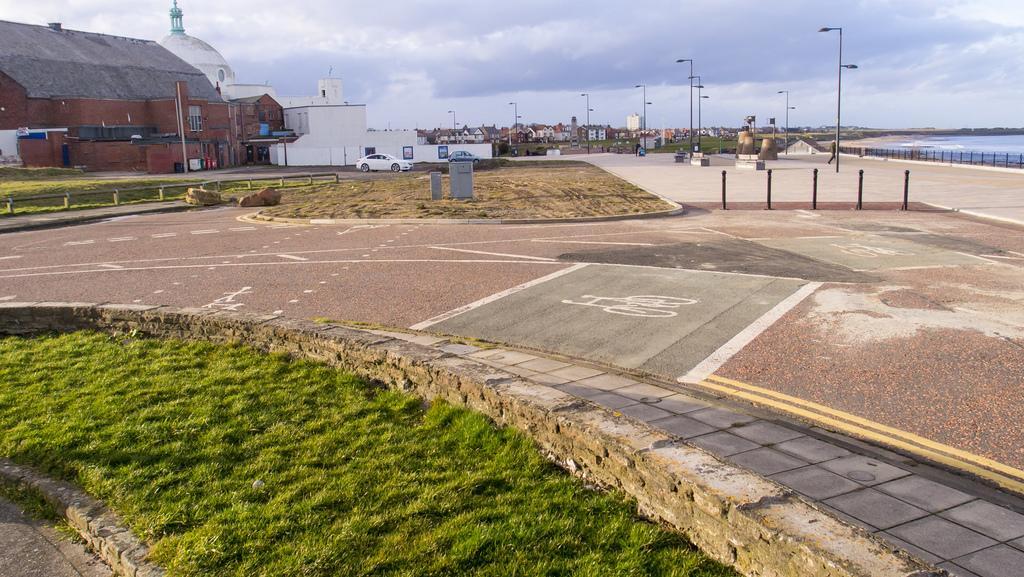In one or two sentences, can you explain what this image depicts? In this image there is a road in the middle and there is a garden on the left side. In the background there are buildings. In front of the building there is a car. On the right side there are electric poles. At the top there is sky. On the right side bottom there is a floor. On the right side top there is a sea. 